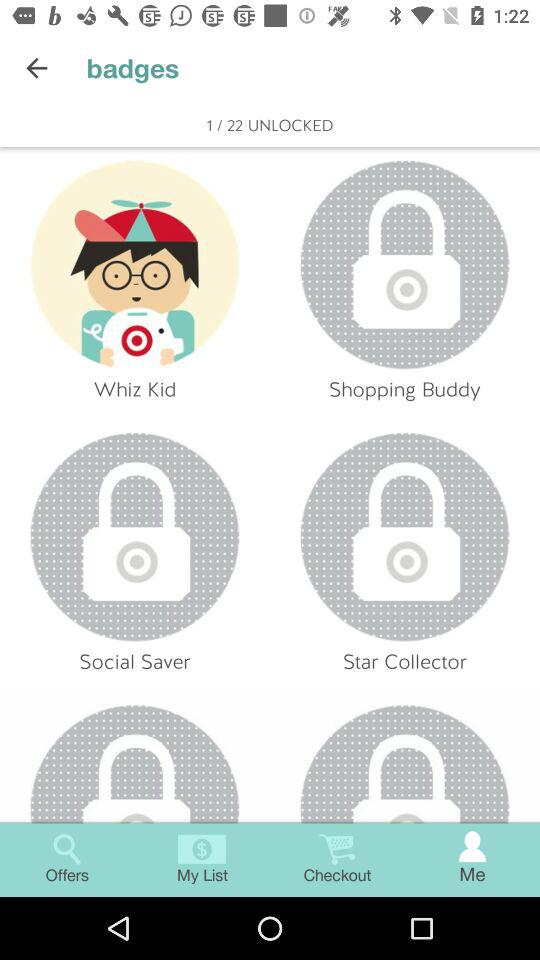How many badges are not unlocked?
Answer the question using a single word or phrase. 21 